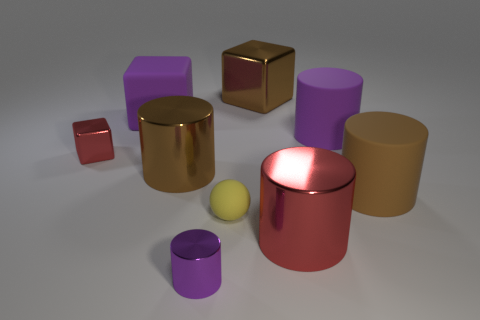There is a purple cylinder that is made of the same material as the purple cube; what is its size?
Your answer should be compact. Large. What color is the large block that is made of the same material as the tiny red block?
Keep it short and to the point. Brown. Are there any yellow rubber cylinders of the same size as the yellow thing?
Give a very brief answer. No. There is another purple object that is the same shape as the small purple thing; what is its material?
Ensure brevity in your answer.  Rubber. There is a red metal thing that is the same size as the brown metallic cylinder; what shape is it?
Offer a terse response. Cylinder. Are there any small brown matte things that have the same shape as the yellow rubber thing?
Make the answer very short. No. What is the shape of the purple thing that is to the right of the rubber sphere to the left of the large brown shiny cube?
Your answer should be very brief. Cylinder. What is the shape of the small purple thing?
Give a very brief answer. Cylinder. There is a big cylinder on the left side of the big brown shiny object that is to the right of the large cylinder that is left of the red metallic cylinder; what is its material?
Offer a terse response. Metal. How many other objects are the same material as the red cube?
Offer a very short reply. 4. 